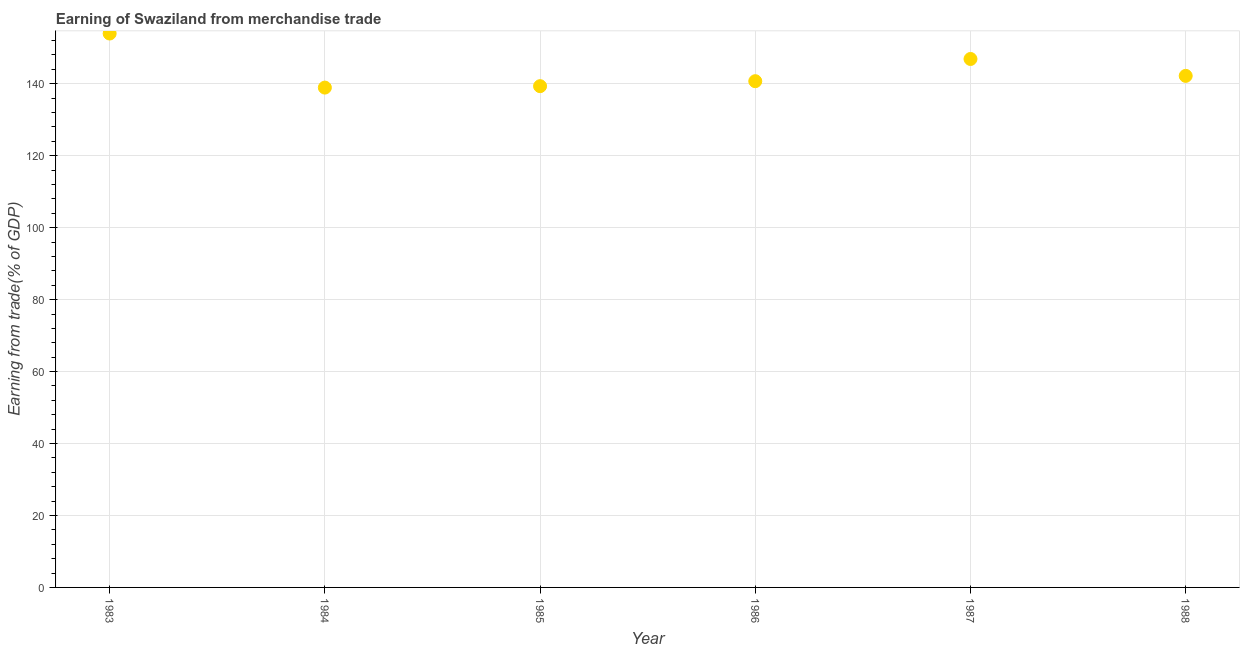What is the earning from merchandise trade in 1986?
Offer a very short reply. 140.71. Across all years, what is the maximum earning from merchandise trade?
Offer a very short reply. 153.96. Across all years, what is the minimum earning from merchandise trade?
Ensure brevity in your answer.  138.93. What is the sum of the earning from merchandise trade?
Provide a short and direct response. 862.01. What is the difference between the earning from merchandise trade in 1986 and 1987?
Make the answer very short. -6.17. What is the average earning from merchandise trade per year?
Your response must be concise. 143.67. What is the median earning from merchandise trade?
Ensure brevity in your answer.  141.45. Do a majority of the years between 1986 and 1985 (inclusive) have earning from merchandise trade greater than 144 %?
Your answer should be very brief. No. What is the ratio of the earning from merchandise trade in 1986 to that in 1988?
Your answer should be compact. 0.99. Is the earning from merchandise trade in 1986 less than that in 1987?
Your answer should be compact. Yes. What is the difference between the highest and the second highest earning from merchandise trade?
Provide a succinct answer. 7.07. Is the sum of the earning from merchandise trade in 1986 and 1988 greater than the maximum earning from merchandise trade across all years?
Give a very brief answer. Yes. What is the difference between the highest and the lowest earning from merchandise trade?
Ensure brevity in your answer.  15.03. In how many years, is the earning from merchandise trade greater than the average earning from merchandise trade taken over all years?
Ensure brevity in your answer.  2. Does the earning from merchandise trade monotonically increase over the years?
Provide a short and direct response. No. How many dotlines are there?
Your response must be concise. 1. What is the difference between two consecutive major ticks on the Y-axis?
Offer a very short reply. 20. Are the values on the major ticks of Y-axis written in scientific E-notation?
Keep it short and to the point. No. Does the graph contain any zero values?
Your response must be concise. No. Does the graph contain grids?
Give a very brief answer. Yes. What is the title of the graph?
Give a very brief answer. Earning of Swaziland from merchandise trade. What is the label or title of the X-axis?
Make the answer very short. Year. What is the label or title of the Y-axis?
Your answer should be compact. Earning from trade(% of GDP). What is the Earning from trade(% of GDP) in 1983?
Ensure brevity in your answer.  153.96. What is the Earning from trade(% of GDP) in 1984?
Provide a short and direct response. 138.93. What is the Earning from trade(% of GDP) in 1985?
Provide a short and direct response. 139.33. What is the Earning from trade(% of GDP) in 1986?
Your answer should be compact. 140.71. What is the Earning from trade(% of GDP) in 1987?
Provide a short and direct response. 146.89. What is the Earning from trade(% of GDP) in 1988?
Ensure brevity in your answer.  142.19. What is the difference between the Earning from trade(% of GDP) in 1983 and 1984?
Ensure brevity in your answer.  15.03. What is the difference between the Earning from trade(% of GDP) in 1983 and 1985?
Provide a short and direct response. 14.63. What is the difference between the Earning from trade(% of GDP) in 1983 and 1986?
Your answer should be compact. 13.25. What is the difference between the Earning from trade(% of GDP) in 1983 and 1987?
Your answer should be very brief. 7.07. What is the difference between the Earning from trade(% of GDP) in 1983 and 1988?
Make the answer very short. 11.77. What is the difference between the Earning from trade(% of GDP) in 1984 and 1985?
Your answer should be very brief. -0.4. What is the difference between the Earning from trade(% of GDP) in 1984 and 1986?
Keep it short and to the point. -1.78. What is the difference between the Earning from trade(% of GDP) in 1984 and 1987?
Make the answer very short. -7.95. What is the difference between the Earning from trade(% of GDP) in 1984 and 1988?
Your answer should be compact. -3.26. What is the difference between the Earning from trade(% of GDP) in 1985 and 1986?
Keep it short and to the point. -1.38. What is the difference between the Earning from trade(% of GDP) in 1985 and 1987?
Provide a succinct answer. -7.56. What is the difference between the Earning from trade(% of GDP) in 1985 and 1988?
Keep it short and to the point. -2.86. What is the difference between the Earning from trade(% of GDP) in 1986 and 1987?
Offer a terse response. -6.17. What is the difference between the Earning from trade(% of GDP) in 1986 and 1988?
Keep it short and to the point. -1.48. What is the difference between the Earning from trade(% of GDP) in 1987 and 1988?
Provide a succinct answer. 4.7. What is the ratio of the Earning from trade(% of GDP) in 1983 to that in 1984?
Offer a very short reply. 1.11. What is the ratio of the Earning from trade(% of GDP) in 1983 to that in 1985?
Your answer should be compact. 1.1. What is the ratio of the Earning from trade(% of GDP) in 1983 to that in 1986?
Provide a short and direct response. 1.09. What is the ratio of the Earning from trade(% of GDP) in 1983 to that in 1987?
Give a very brief answer. 1.05. What is the ratio of the Earning from trade(% of GDP) in 1983 to that in 1988?
Keep it short and to the point. 1.08. What is the ratio of the Earning from trade(% of GDP) in 1984 to that in 1986?
Give a very brief answer. 0.99. What is the ratio of the Earning from trade(% of GDP) in 1984 to that in 1987?
Your answer should be compact. 0.95. What is the ratio of the Earning from trade(% of GDP) in 1984 to that in 1988?
Your response must be concise. 0.98. What is the ratio of the Earning from trade(% of GDP) in 1985 to that in 1987?
Give a very brief answer. 0.95. What is the ratio of the Earning from trade(% of GDP) in 1985 to that in 1988?
Offer a terse response. 0.98. What is the ratio of the Earning from trade(% of GDP) in 1986 to that in 1987?
Your answer should be compact. 0.96. What is the ratio of the Earning from trade(% of GDP) in 1987 to that in 1988?
Your answer should be very brief. 1.03. 